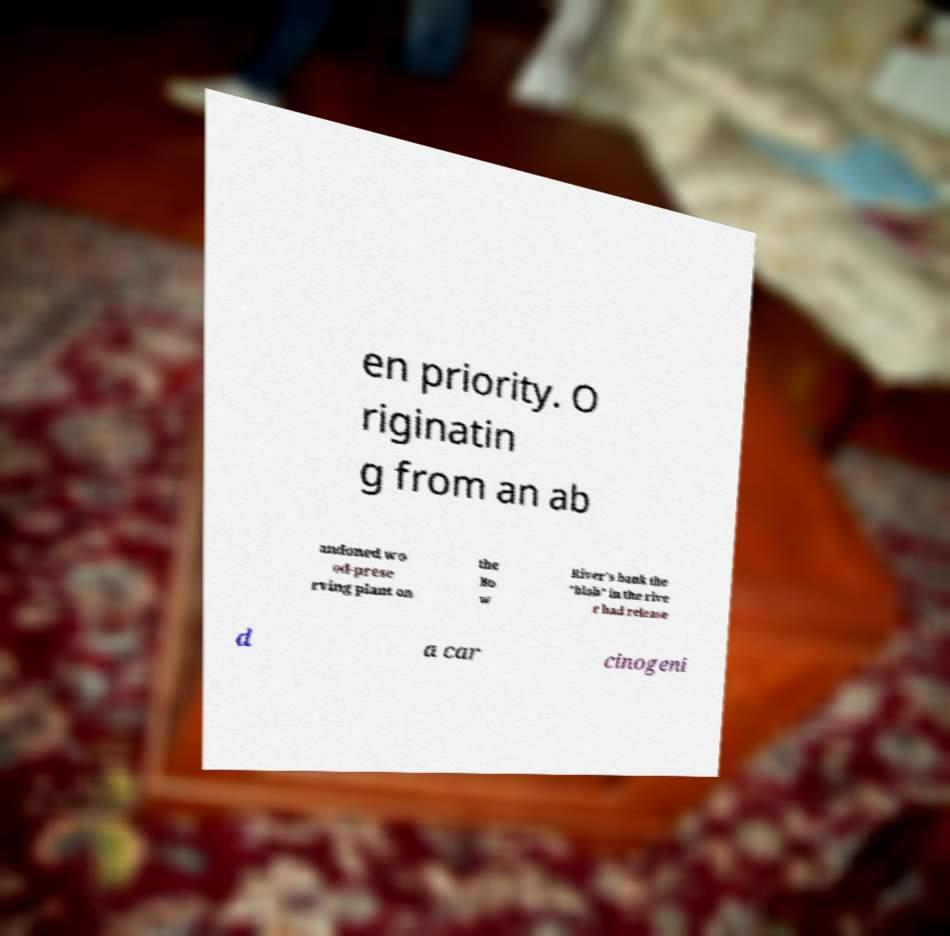Could you extract and type out the text from this image? en priority. O riginatin g from an ab andoned wo od-prese rving plant on the Bo w River's bank the "blob" in the rive r had release d a car cinogeni 